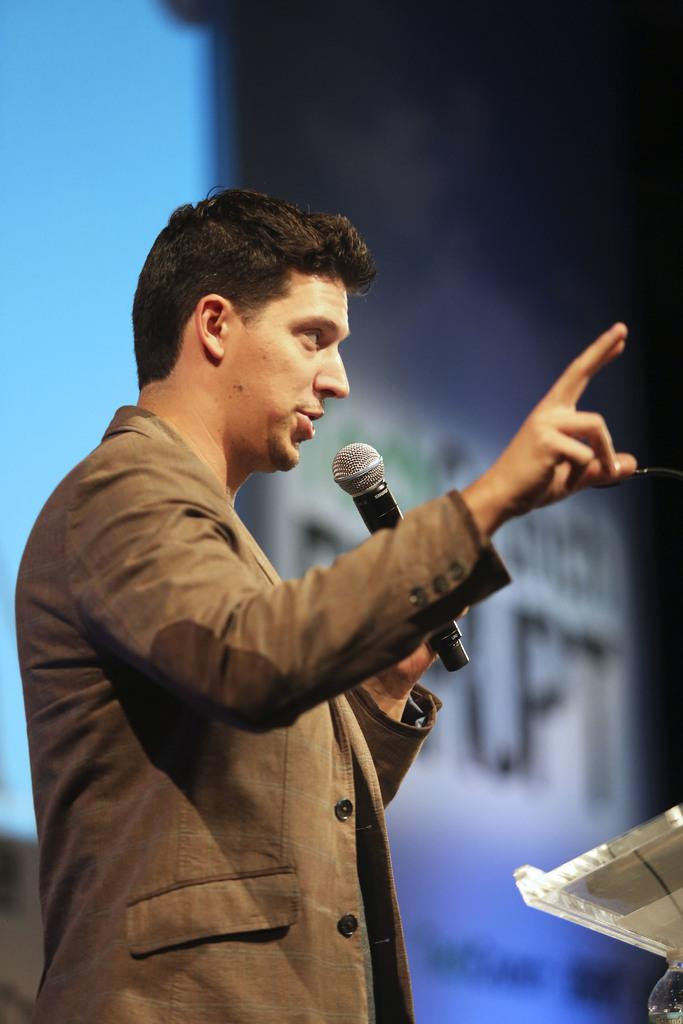What is the main subject of the image? The main subject of the image is a man. What is the man wearing in the image? The man is wearing a grey jacket in the image. What is the man holding in his left hand? The man is holding a microphone in his left hand in the image. What is the man doing with his right hand? The man is raising his right hand in the image. What route is the man taking to get to work in the image? There is no information about the man's route or work in the image; it only shows him holding a microphone and raising his right hand. 